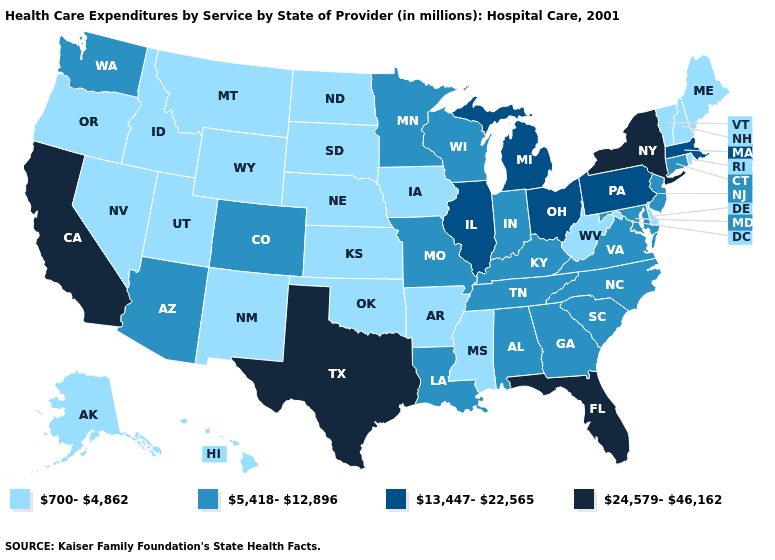Name the states that have a value in the range 13,447-22,565?
Write a very short answer. Illinois, Massachusetts, Michigan, Ohio, Pennsylvania. Does Michigan have the lowest value in the USA?
Concise answer only. No. Among the states that border Mississippi , does Alabama have the highest value?
Short answer required. Yes. Name the states that have a value in the range 24,579-46,162?
Write a very short answer. California, Florida, New York, Texas. What is the value of Nevada?
Write a very short answer. 700-4,862. What is the highest value in the MidWest ?
Quick response, please. 13,447-22,565. Among the states that border Indiana , which have the lowest value?
Be succinct. Kentucky. Which states have the lowest value in the USA?
Be succinct. Alaska, Arkansas, Delaware, Hawaii, Idaho, Iowa, Kansas, Maine, Mississippi, Montana, Nebraska, Nevada, New Hampshire, New Mexico, North Dakota, Oklahoma, Oregon, Rhode Island, South Dakota, Utah, Vermont, West Virginia, Wyoming. What is the value of Nebraska?
Keep it brief. 700-4,862. What is the value of Tennessee?
Answer briefly. 5,418-12,896. Which states hav the highest value in the MidWest?
Quick response, please. Illinois, Michigan, Ohio. Which states have the lowest value in the USA?
Concise answer only. Alaska, Arkansas, Delaware, Hawaii, Idaho, Iowa, Kansas, Maine, Mississippi, Montana, Nebraska, Nevada, New Hampshire, New Mexico, North Dakota, Oklahoma, Oregon, Rhode Island, South Dakota, Utah, Vermont, West Virginia, Wyoming. What is the value of Maine?
Write a very short answer. 700-4,862. What is the value of Minnesota?
Write a very short answer. 5,418-12,896. Which states have the highest value in the USA?
Short answer required. California, Florida, New York, Texas. 